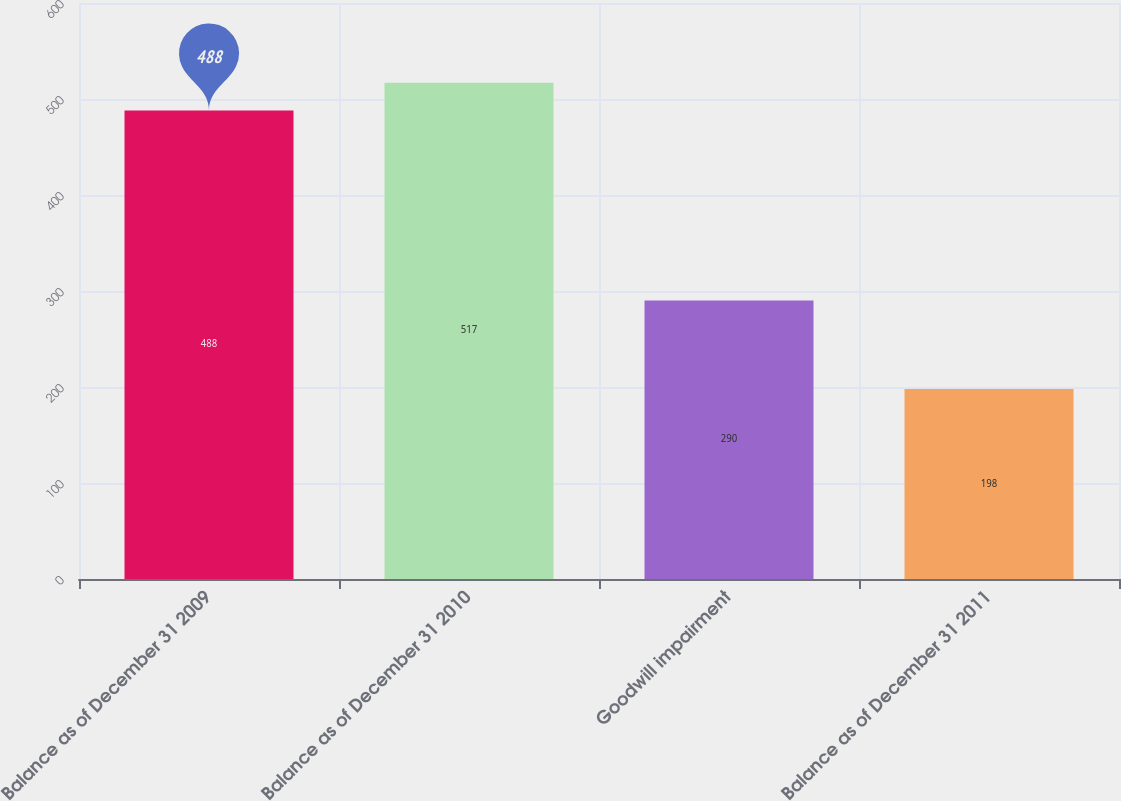<chart> <loc_0><loc_0><loc_500><loc_500><bar_chart><fcel>Balance as of December 31 2009<fcel>Balance as of December 31 2010<fcel>Goodwill impairment<fcel>Balance as of December 31 2011<nl><fcel>488<fcel>517<fcel>290<fcel>198<nl></chart> 